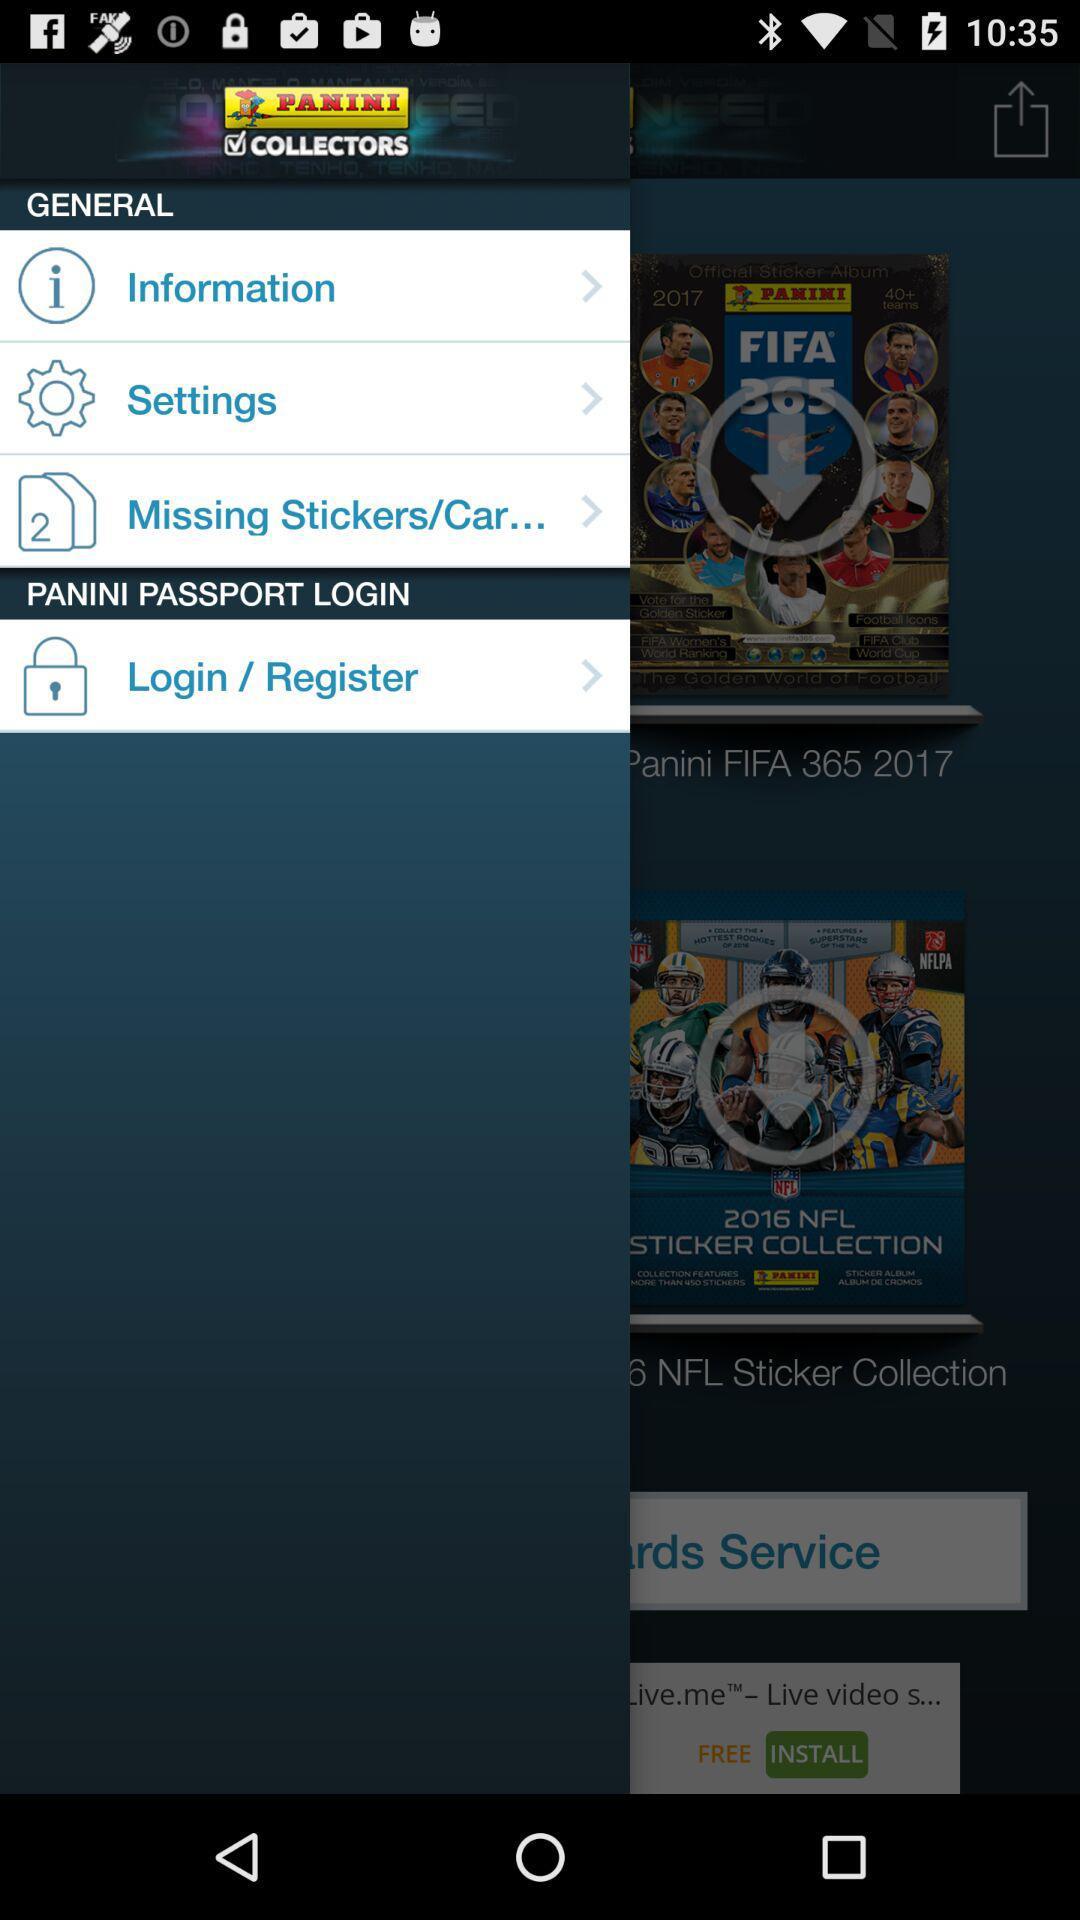How many notifications are there in "Settings"?
When the provided information is insufficient, respond with <no answer>. <no answer> 